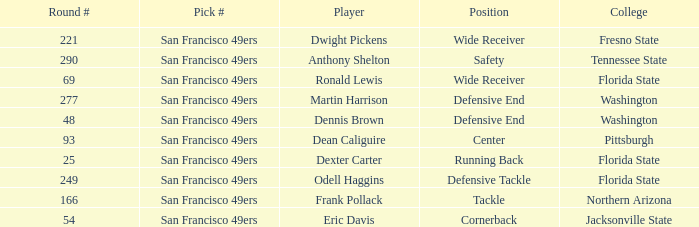What is the College with a Round # that is 290? Tennessee State. 